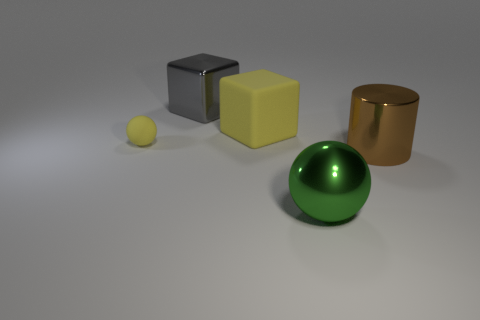What is the shape of the thing that is both in front of the big yellow thing and behind the brown metallic cylinder?
Make the answer very short. Sphere. Is the shape of the big yellow matte object the same as the large shiny thing that is behind the large metallic cylinder?
Offer a terse response. Yes. There is a yellow cube; are there any large green shiny balls in front of it?
Provide a short and direct response. Yes. What number of cylinders are either big yellow rubber things or large green metallic things?
Your answer should be compact. 0. Do the tiny yellow thing and the large green object have the same shape?
Provide a succinct answer. Yes. What is the size of the yellow rubber thing on the right side of the big gray shiny cube?
Provide a succinct answer. Large. Are there any tiny spheres that have the same color as the large matte object?
Give a very brief answer. Yes. There is a metallic thing on the left side of the green object; is it the same size as the big yellow object?
Ensure brevity in your answer.  Yes. What is the color of the big metal block?
Your answer should be very brief. Gray. What is the color of the big metallic thing on the left side of the ball that is right of the small object?
Give a very brief answer. Gray. 